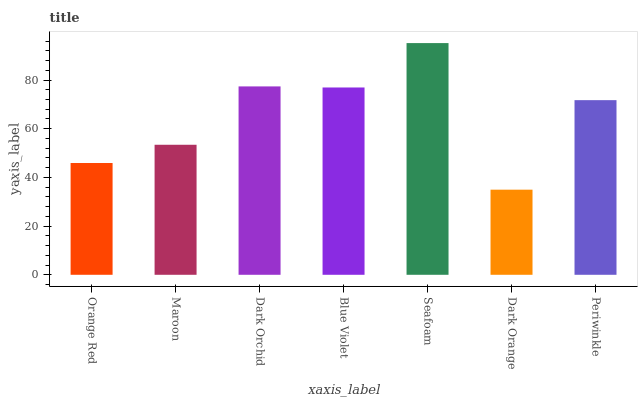Is Dark Orange the minimum?
Answer yes or no. Yes. Is Seafoam the maximum?
Answer yes or no. Yes. Is Maroon the minimum?
Answer yes or no. No. Is Maroon the maximum?
Answer yes or no. No. Is Maroon greater than Orange Red?
Answer yes or no. Yes. Is Orange Red less than Maroon?
Answer yes or no. Yes. Is Orange Red greater than Maroon?
Answer yes or no. No. Is Maroon less than Orange Red?
Answer yes or no. No. Is Periwinkle the high median?
Answer yes or no. Yes. Is Periwinkle the low median?
Answer yes or no. Yes. Is Maroon the high median?
Answer yes or no. No. Is Maroon the low median?
Answer yes or no. No. 